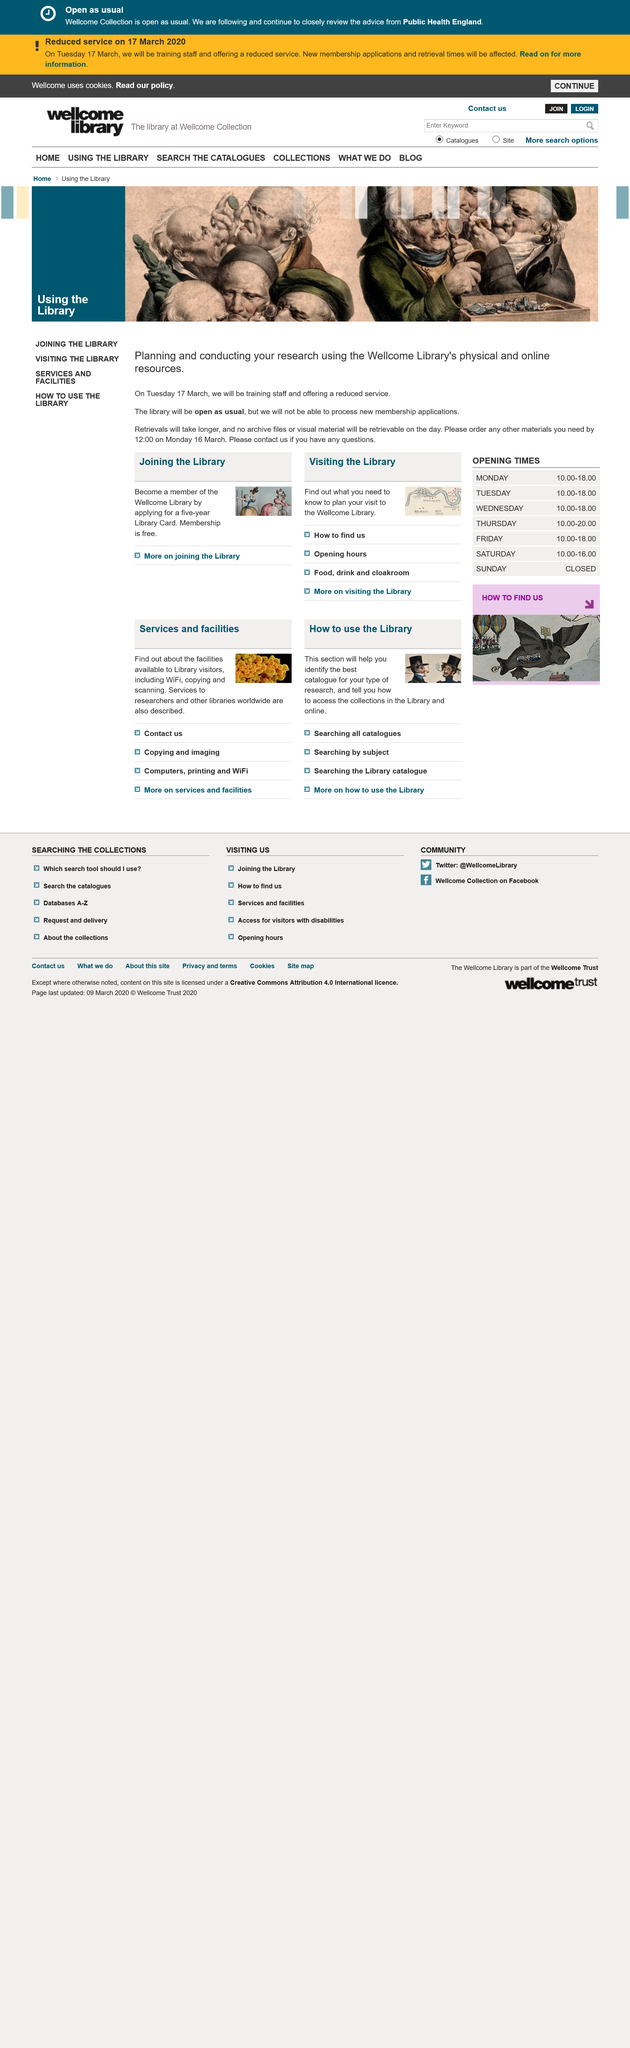List a handful of essential elements in this visual. If you have questions, it is recommended that you contact them. Retrievals will take longer than usual. On that day, they will not be able to process new membership applications. 